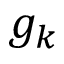Convert formula to latex. <formula><loc_0><loc_0><loc_500><loc_500>g _ { k }</formula> 